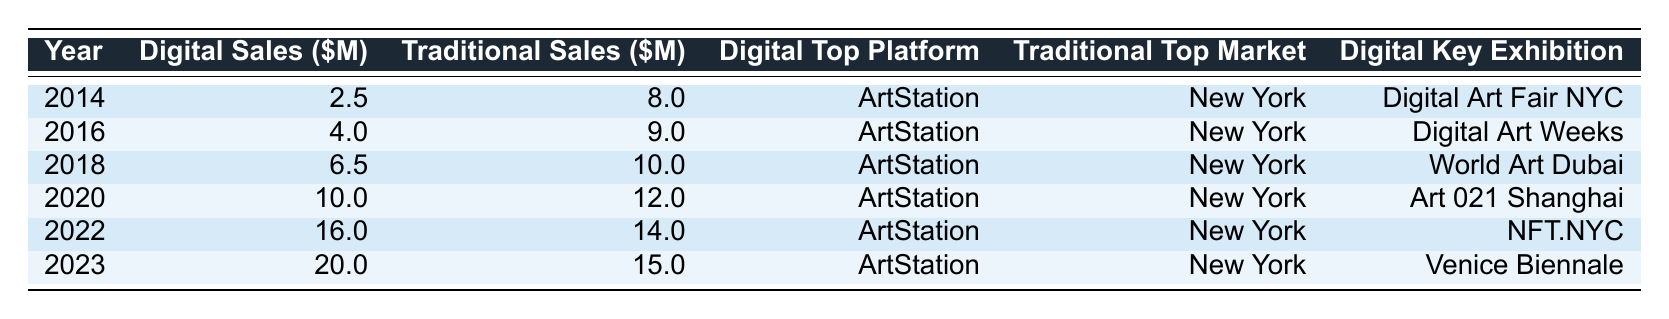What was the total digital art sales in 2022? In the table, the row for the year 2022 shows that the total digital art sales amounted to 16 million dollars.
Answer: 16.0 What is the top platform for digital art sales in 2023? The row for the year 2023 indicates that the top platform for digital art sales is ArtStation.
Answer: ArtStation What are the total traditional art sales for 2019? According to the table, the total traditional art sales for 2019 is 11 million dollars.
Answer: 11.0 Which year saw the highest digital art sales? By examining the total digital art sales for each year, 2023 has the highest sales, totaling 20 million dollars.
Answer: 2023 What is the difference between digital and traditional art sales in 2022? Total digital sales in 2022 were 16 million and traditional sales were 14 million. The difference is 16 million - 14 million = 2 million.
Answer: 2.0 Was the top market for traditional art sales always New York from 2014 to 2023? Yes, in each year listed from 2014 to 2023, New York has consistently been the top market for traditional art sales.
Answer: Yes What was the average total sales for digital art from 2014 to 2023? First, add the total sales from each year: 2.5 + 4 + 6.5 + 10 + 16 + 20 = 59 million. Then, divide by the number of years, which is 10: 59 million / 10 = 5.9 million.
Answer: 5.9 What was the typical key exhibition for digital art sales every year? Reviewing the key exhibitions, there is no single 'typical' exhibition as different exhibitions were highlighted each year, indicating a variety of showcases.
Answer: No What was the growth in total digital art sales from 2014 to 2023? The total sales in 2014 were 2.5 million and in 2023 they reached 20 million. The growth is calculated as 20 million - 2.5 million = 17.5 million.
Answer: 17.5 How did traditional art sales in 2020 compare to those in 2018? Traditional art sales in 2020 were 12 million and in 2018 they were 10 million. The comparison shows an increase of 2 million.
Answer: 2.0 Which year experienced a faster growth in total digital art sales: 2019 to 2020 or 2020 to 2021? In 2019, sales were 8 million, and in 2020, they were 10 million, which is an increase of 2 million. In 2020, sales were 10 million, and in 2021, they were 13 million, which is an increase of 3 million. Thus, 2020 to 2021 experienced faster growth.
Answer: 2020 to 2021 